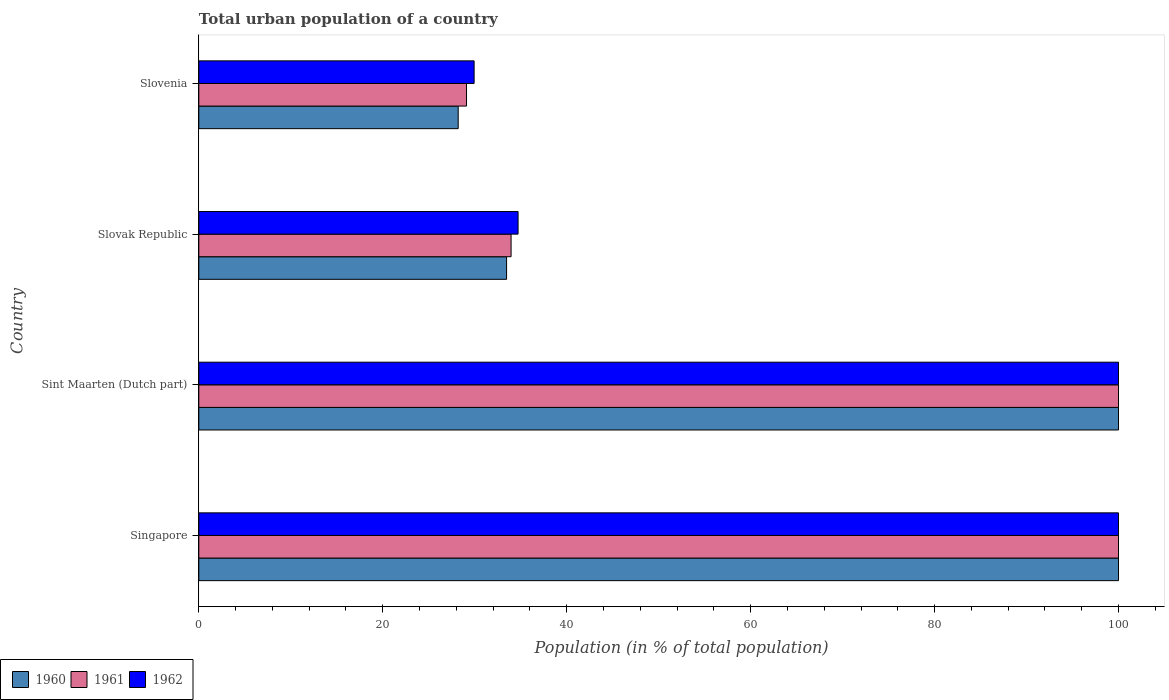How many groups of bars are there?
Offer a very short reply. 4. Are the number of bars per tick equal to the number of legend labels?
Your answer should be compact. Yes. Are the number of bars on each tick of the Y-axis equal?
Your response must be concise. Yes. What is the label of the 2nd group of bars from the top?
Your answer should be compact. Slovak Republic. What is the urban population in 1960 in Singapore?
Offer a terse response. 100. Across all countries, what is the maximum urban population in 1962?
Offer a terse response. 100. Across all countries, what is the minimum urban population in 1962?
Your answer should be compact. 29.93. In which country was the urban population in 1961 maximum?
Provide a short and direct response. Singapore. In which country was the urban population in 1962 minimum?
Provide a short and direct response. Slovenia. What is the total urban population in 1960 in the graph?
Offer a terse response. 261.67. What is the difference between the urban population in 1960 in Sint Maarten (Dutch part) and that in Slovak Republic?
Your answer should be compact. 66.54. What is the difference between the urban population in 1961 in Slovak Republic and the urban population in 1960 in Singapore?
Your answer should be compact. -66.05. What is the average urban population in 1960 per country?
Ensure brevity in your answer.  65.42. In how many countries, is the urban population in 1962 greater than 20 %?
Give a very brief answer. 4. What is the ratio of the urban population in 1962 in Singapore to that in Slovak Republic?
Ensure brevity in your answer.  2.88. Is the difference between the urban population in 1960 in Sint Maarten (Dutch part) and Slovak Republic greater than the difference between the urban population in 1961 in Sint Maarten (Dutch part) and Slovak Republic?
Offer a terse response. Yes. What is the difference between the highest and the second highest urban population in 1962?
Keep it short and to the point. 0. What is the difference between the highest and the lowest urban population in 1961?
Offer a very short reply. 70.89. How many bars are there?
Make the answer very short. 12. What is the difference between two consecutive major ticks on the X-axis?
Keep it short and to the point. 20. Are the values on the major ticks of X-axis written in scientific E-notation?
Your answer should be compact. No. Does the graph contain any zero values?
Provide a succinct answer. No. Does the graph contain grids?
Offer a very short reply. No. Where does the legend appear in the graph?
Provide a succinct answer. Bottom left. How many legend labels are there?
Your answer should be compact. 3. What is the title of the graph?
Your answer should be very brief. Total urban population of a country. Does "1994" appear as one of the legend labels in the graph?
Provide a succinct answer. No. What is the label or title of the X-axis?
Offer a very short reply. Population (in % of total population). What is the label or title of the Y-axis?
Provide a succinct answer. Country. What is the Population (in % of total population) of 1960 in Sint Maarten (Dutch part)?
Offer a very short reply. 100. What is the Population (in % of total population) of 1961 in Sint Maarten (Dutch part)?
Offer a terse response. 100. What is the Population (in % of total population) in 1960 in Slovak Republic?
Give a very brief answer. 33.46. What is the Population (in % of total population) of 1961 in Slovak Republic?
Provide a short and direct response. 33.95. What is the Population (in % of total population) in 1962 in Slovak Republic?
Provide a succinct answer. 34.71. What is the Population (in % of total population) of 1960 in Slovenia?
Your response must be concise. 28.2. What is the Population (in % of total population) of 1961 in Slovenia?
Offer a terse response. 29.11. What is the Population (in % of total population) of 1962 in Slovenia?
Provide a short and direct response. 29.93. Across all countries, what is the maximum Population (in % of total population) in 1960?
Your answer should be very brief. 100. Across all countries, what is the minimum Population (in % of total population) of 1960?
Make the answer very short. 28.2. Across all countries, what is the minimum Population (in % of total population) of 1961?
Offer a terse response. 29.11. Across all countries, what is the minimum Population (in % of total population) of 1962?
Your answer should be very brief. 29.93. What is the total Population (in % of total population) in 1960 in the graph?
Keep it short and to the point. 261.67. What is the total Population (in % of total population) of 1961 in the graph?
Ensure brevity in your answer.  263.06. What is the total Population (in % of total population) of 1962 in the graph?
Keep it short and to the point. 264.65. What is the difference between the Population (in % of total population) of 1961 in Singapore and that in Sint Maarten (Dutch part)?
Ensure brevity in your answer.  0. What is the difference between the Population (in % of total population) of 1962 in Singapore and that in Sint Maarten (Dutch part)?
Make the answer very short. 0. What is the difference between the Population (in % of total population) in 1960 in Singapore and that in Slovak Republic?
Keep it short and to the point. 66.54. What is the difference between the Population (in % of total population) in 1961 in Singapore and that in Slovak Republic?
Give a very brief answer. 66.05. What is the difference between the Population (in % of total population) in 1962 in Singapore and that in Slovak Republic?
Your answer should be compact. 65.29. What is the difference between the Population (in % of total population) in 1960 in Singapore and that in Slovenia?
Make the answer very short. 71.8. What is the difference between the Population (in % of total population) in 1961 in Singapore and that in Slovenia?
Give a very brief answer. 70.89. What is the difference between the Population (in % of total population) in 1962 in Singapore and that in Slovenia?
Offer a very short reply. 70.07. What is the difference between the Population (in % of total population) of 1960 in Sint Maarten (Dutch part) and that in Slovak Republic?
Provide a short and direct response. 66.54. What is the difference between the Population (in % of total population) in 1961 in Sint Maarten (Dutch part) and that in Slovak Republic?
Make the answer very short. 66.05. What is the difference between the Population (in % of total population) of 1962 in Sint Maarten (Dutch part) and that in Slovak Republic?
Offer a terse response. 65.29. What is the difference between the Population (in % of total population) of 1960 in Sint Maarten (Dutch part) and that in Slovenia?
Your response must be concise. 71.8. What is the difference between the Population (in % of total population) in 1961 in Sint Maarten (Dutch part) and that in Slovenia?
Your answer should be very brief. 70.89. What is the difference between the Population (in % of total population) of 1962 in Sint Maarten (Dutch part) and that in Slovenia?
Give a very brief answer. 70.07. What is the difference between the Population (in % of total population) in 1960 in Slovak Republic and that in Slovenia?
Make the answer very short. 5.26. What is the difference between the Population (in % of total population) of 1961 in Slovak Republic and that in Slovenia?
Make the answer very short. 4.85. What is the difference between the Population (in % of total population) of 1962 in Slovak Republic and that in Slovenia?
Your answer should be very brief. 4.78. What is the difference between the Population (in % of total population) of 1960 in Singapore and the Population (in % of total population) of 1962 in Sint Maarten (Dutch part)?
Give a very brief answer. 0. What is the difference between the Population (in % of total population) of 1961 in Singapore and the Population (in % of total population) of 1962 in Sint Maarten (Dutch part)?
Ensure brevity in your answer.  0. What is the difference between the Population (in % of total population) of 1960 in Singapore and the Population (in % of total population) of 1961 in Slovak Republic?
Provide a succinct answer. 66.05. What is the difference between the Population (in % of total population) of 1960 in Singapore and the Population (in % of total population) of 1962 in Slovak Republic?
Make the answer very short. 65.29. What is the difference between the Population (in % of total population) in 1961 in Singapore and the Population (in % of total population) in 1962 in Slovak Republic?
Provide a succinct answer. 65.29. What is the difference between the Population (in % of total population) in 1960 in Singapore and the Population (in % of total population) in 1961 in Slovenia?
Provide a succinct answer. 70.89. What is the difference between the Population (in % of total population) in 1960 in Singapore and the Population (in % of total population) in 1962 in Slovenia?
Your answer should be compact. 70.07. What is the difference between the Population (in % of total population) in 1961 in Singapore and the Population (in % of total population) in 1962 in Slovenia?
Provide a short and direct response. 70.07. What is the difference between the Population (in % of total population) of 1960 in Sint Maarten (Dutch part) and the Population (in % of total population) of 1961 in Slovak Republic?
Offer a terse response. 66.05. What is the difference between the Population (in % of total population) in 1960 in Sint Maarten (Dutch part) and the Population (in % of total population) in 1962 in Slovak Republic?
Keep it short and to the point. 65.29. What is the difference between the Population (in % of total population) in 1961 in Sint Maarten (Dutch part) and the Population (in % of total population) in 1962 in Slovak Republic?
Make the answer very short. 65.29. What is the difference between the Population (in % of total population) of 1960 in Sint Maarten (Dutch part) and the Population (in % of total population) of 1961 in Slovenia?
Keep it short and to the point. 70.89. What is the difference between the Population (in % of total population) in 1960 in Sint Maarten (Dutch part) and the Population (in % of total population) in 1962 in Slovenia?
Provide a short and direct response. 70.07. What is the difference between the Population (in % of total population) of 1961 in Sint Maarten (Dutch part) and the Population (in % of total population) of 1962 in Slovenia?
Give a very brief answer. 70.07. What is the difference between the Population (in % of total population) in 1960 in Slovak Republic and the Population (in % of total population) in 1961 in Slovenia?
Your response must be concise. 4.36. What is the difference between the Population (in % of total population) in 1960 in Slovak Republic and the Population (in % of total population) in 1962 in Slovenia?
Provide a short and direct response. 3.53. What is the difference between the Population (in % of total population) of 1961 in Slovak Republic and the Population (in % of total population) of 1962 in Slovenia?
Offer a terse response. 4.02. What is the average Population (in % of total population) of 1960 per country?
Your answer should be very brief. 65.42. What is the average Population (in % of total population) in 1961 per country?
Ensure brevity in your answer.  65.77. What is the average Population (in % of total population) in 1962 per country?
Your answer should be very brief. 66.16. What is the difference between the Population (in % of total population) of 1960 and Population (in % of total population) of 1961 in Singapore?
Your answer should be very brief. 0. What is the difference between the Population (in % of total population) of 1960 and Population (in % of total population) of 1962 in Singapore?
Provide a short and direct response. 0. What is the difference between the Population (in % of total population) in 1961 and Population (in % of total population) in 1962 in Singapore?
Provide a succinct answer. 0. What is the difference between the Population (in % of total population) in 1960 and Population (in % of total population) in 1961 in Sint Maarten (Dutch part)?
Ensure brevity in your answer.  0. What is the difference between the Population (in % of total population) of 1960 and Population (in % of total population) of 1961 in Slovak Republic?
Provide a short and direct response. -0.49. What is the difference between the Population (in % of total population) of 1960 and Population (in % of total population) of 1962 in Slovak Republic?
Ensure brevity in your answer.  -1.25. What is the difference between the Population (in % of total population) in 1961 and Population (in % of total population) in 1962 in Slovak Republic?
Your answer should be compact. -0.76. What is the difference between the Population (in % of total population) of 1960 and Population (in % of total population) of 1961 in Slovenia?
Ensure brevity in your answer.  -0.9. What is the difference between the Population (in % of total population) in 1960 and Population (in % of total population) in 1962 in Slovenia?
Give a very brief answer. -1.73. What is the difference between the Population (in % of total population) of 1961 and Population (in % of total population) of 1962 in Slovenia?
Your response must be concise. -0.83. What is the ratio of the Population (in % of total population) in 1962 in Singapore to that in Sint Maarten (Dutch part)?
Ensure brevity in your answer.  1. What is the ratio of the Population (in % of total population) in 1960 in Singapore to that in Slovak Republic?
Your answer should be compact. 2.99. What is the ratio of the Population (in % of total population) of 1961 in Singapore to that in Slovak Republic?
Keep it short and to the point. 2.95. What is the ratio of the Population (in % of total population) in 1962 in Singapore to that in Slovak Republic?
Your response must be concise. 2.88. What is the ratio of the Population (in % of total population) of 1960 in Singapore to that in Slovenia?
Provide a short and direct response. 3.55. What is the ratio of the Population (in % of total population) of 1961 in Singapore to that in Slovenia?
Your response must be concise. 3.44. What is the ratio of the Population (in % of total population) of 1962 in Singapore to that in Slovenia?
Offer a terse response. 3.34. What is the ratio of the Population (in % of total population) of 1960 in Sint Maarten (Dutch part) to that in Slovak Republic?
Provide a succinct answer. 2.99. What is the ratio of the Population (in % of total population) of 1961 in Sint Maarten (Dutch part) to that in Slovak Republic?
Provide a short and direct response. 2.95. What is the ratio of the Population (in % of total population) of 1962 in Sint Maarten (Dutch part) to that in Slovak Republic?
Offer a very short reply. 2.88. What is the ratio of the Population (in % of total population) of 1960 in Sint Maarten (Dutch part) to that in Slovenia?
Your response must be concise. 3.55. What is the ratio of the Population (in % of total population) in 1961 in Sint Maarten (Dutch part) to that in Slovenia?
Your response must be concise. 3.44. What is the ratio of the Population (in % of total population) of 1962 in Sint Maarten (Dutch part) to that in Slovenia?
Keep it short and to the point. 3.34. What is the ratio of the Population (in % of total population) in 1960 in Slovak Republic to that in Slovenia?
Your answer should be very brief. 1.19. What is the ratio of the Population (in % of total population) of 1961 in Slovak Republic to that in Slovenia?
Offer a very short reply. 1.17. What is the ratio of the Population (in % of total population) in 1962 in Slovak Republic to that in Slovenia?
Offer a very short reply. 1.16. What is the difference between the highest and the lowest Population (in % of total population) of 1960?
Keep it short and to the point. 71.8. What is the difference between the highest and the lowest Population (in % of total population) in 1961?
Provide a succinct answer. 70.89. What is the difference between the highest and the lowest Population (in % of total population) of 1962?
Your response must be concise. 70.07. 